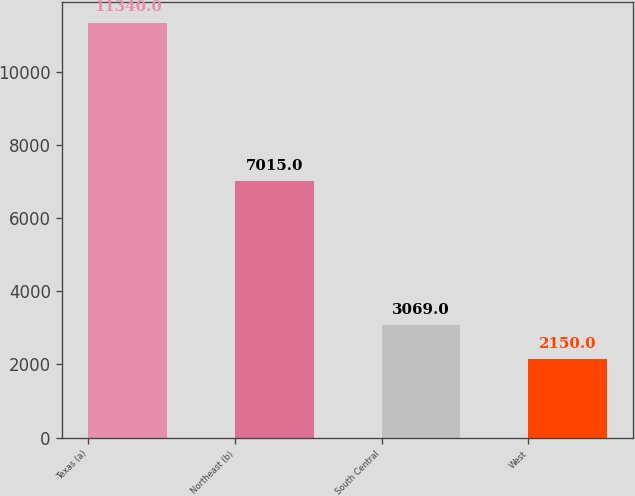<chart> <loc_0><loc_0><loc_500><loc_500><bar_chart><fcel>Texas (a)<fcel>Northeast (b)<fcel>South Central<fcel>West<nl><fcel>11340<fcel>7015<fcel>3069<fcel>2150<nl></chart> 